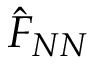<formula> <loc_0><loc_0><loc_500><loc_500>\hat { F } _ { N N }</formula> 